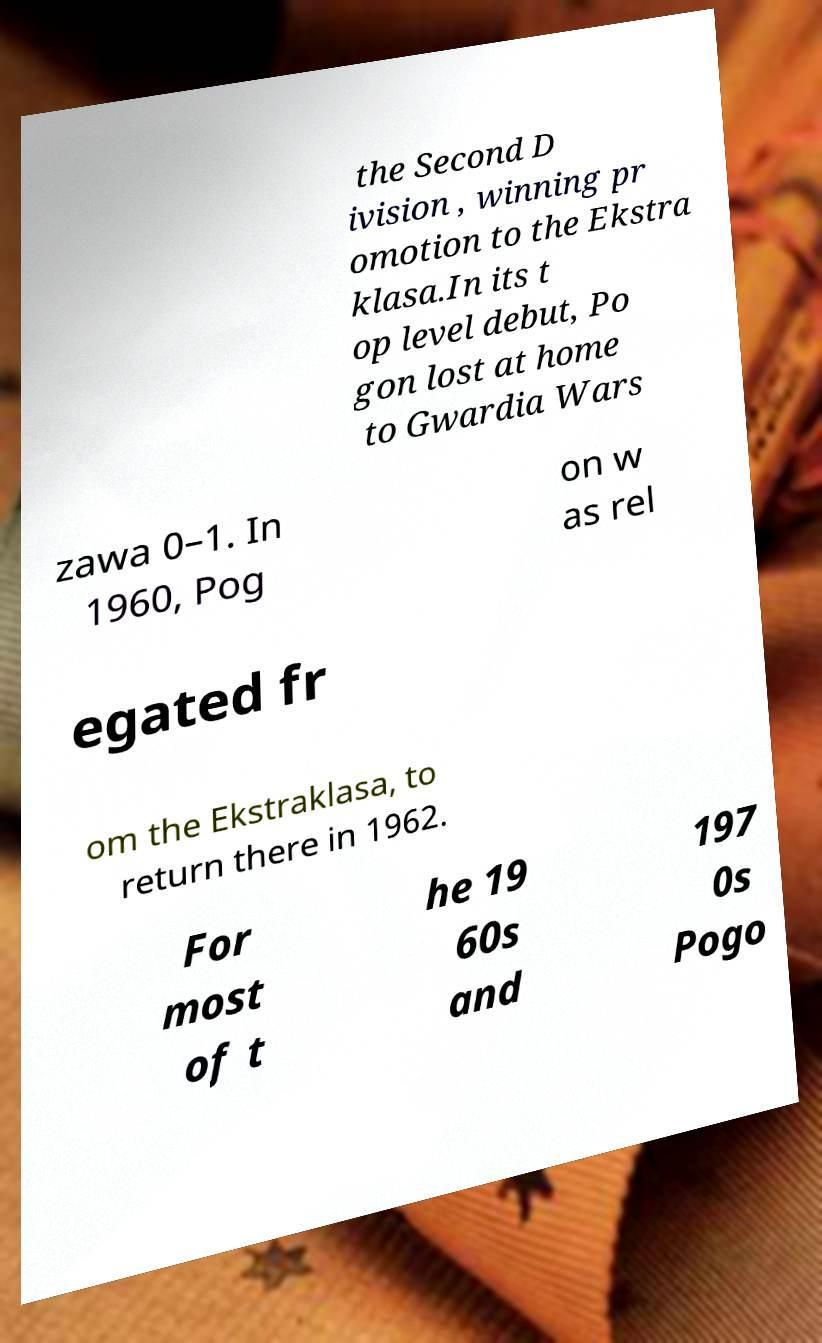There's text embedded in this image that I need extracted. Can you transcribe it verbatim? the Second D ivision , winning pr omotion to the Ekstra klasa.In its t op level debut, Po gon lost at home to Gwardia Wars zawa 0–1. In 1960, Pog on w as rel egated fr om the Ekstraklasa, to return there in 1962. For most of t he 19 60s and 197 0s Pogo 